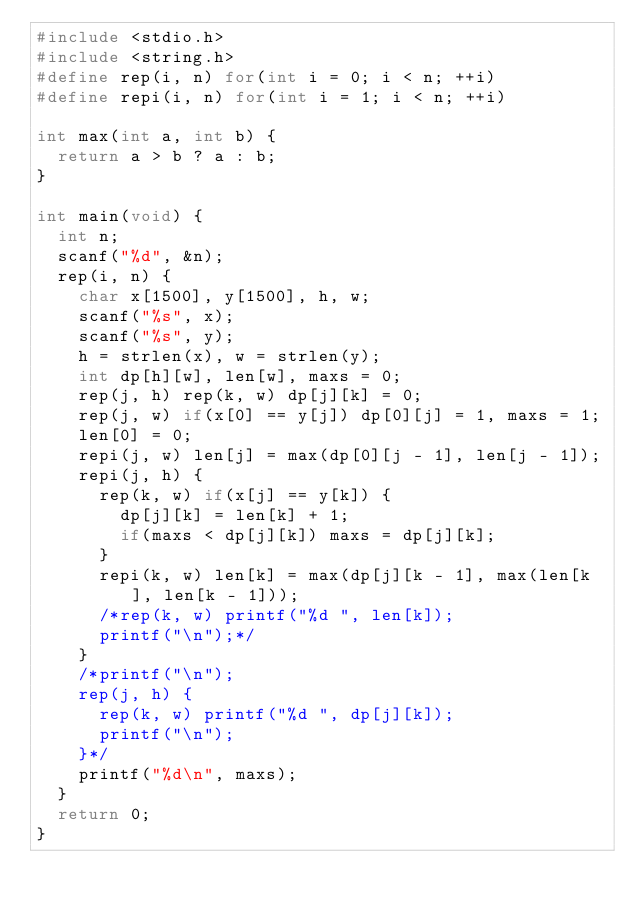<code> <loc_0><loc_0><loc_500><loc_500><_C++_>#include <stdio.h>
#include <string.h>
#define rep(i, n) for(int i = 0; i < n; ++i)
#define repi(i, n) for(int i = 1; i < n; ++i)

int max(int a, int b) {
  return a > b ? a : b;
}

int main(void) {
  int n;
  scanf("%d", &n);
  rep(i, n) {
    char x[1500], y[1500], h, w;
    scanf("%s", x);
    scanf("%s", y);
    h = strlen(x), w = strlen(y);
    int dp[h][w], len[w], maxs = 0;
    rep(j, h) rep(k, w) dp[j][k] = 0;
    rep(j, w) if(x[0] == y[j]) dp[0][j] = 1, maxs = 1;
    len[0] = 0;
    repi(j, w) len[j] = max(dp[0][j - 1], len[j - 1]);
    repi(j, h) {
      rep(k, w) if(x[j] == y[k]) {
        dp[j][k] = len[k] + 1;
        if(maxs < dp[j][k]) maxs = dp[j][k];
      }
      repi(k, w) len[k] = max(dp[j][k - 1], max(len[k], len[k - 1]));
      /*rep(k, w) printf("%d ", len[k]);
      printf("\n");*/
    }
    /*printf("\n");
    rep(j, h) {
      rep(k, w) printf("%d ", dp[j][k]);
      printf("\n");
    }*/
    printf("%d\n", maxs);
  }
  return 0;
}
</code> 